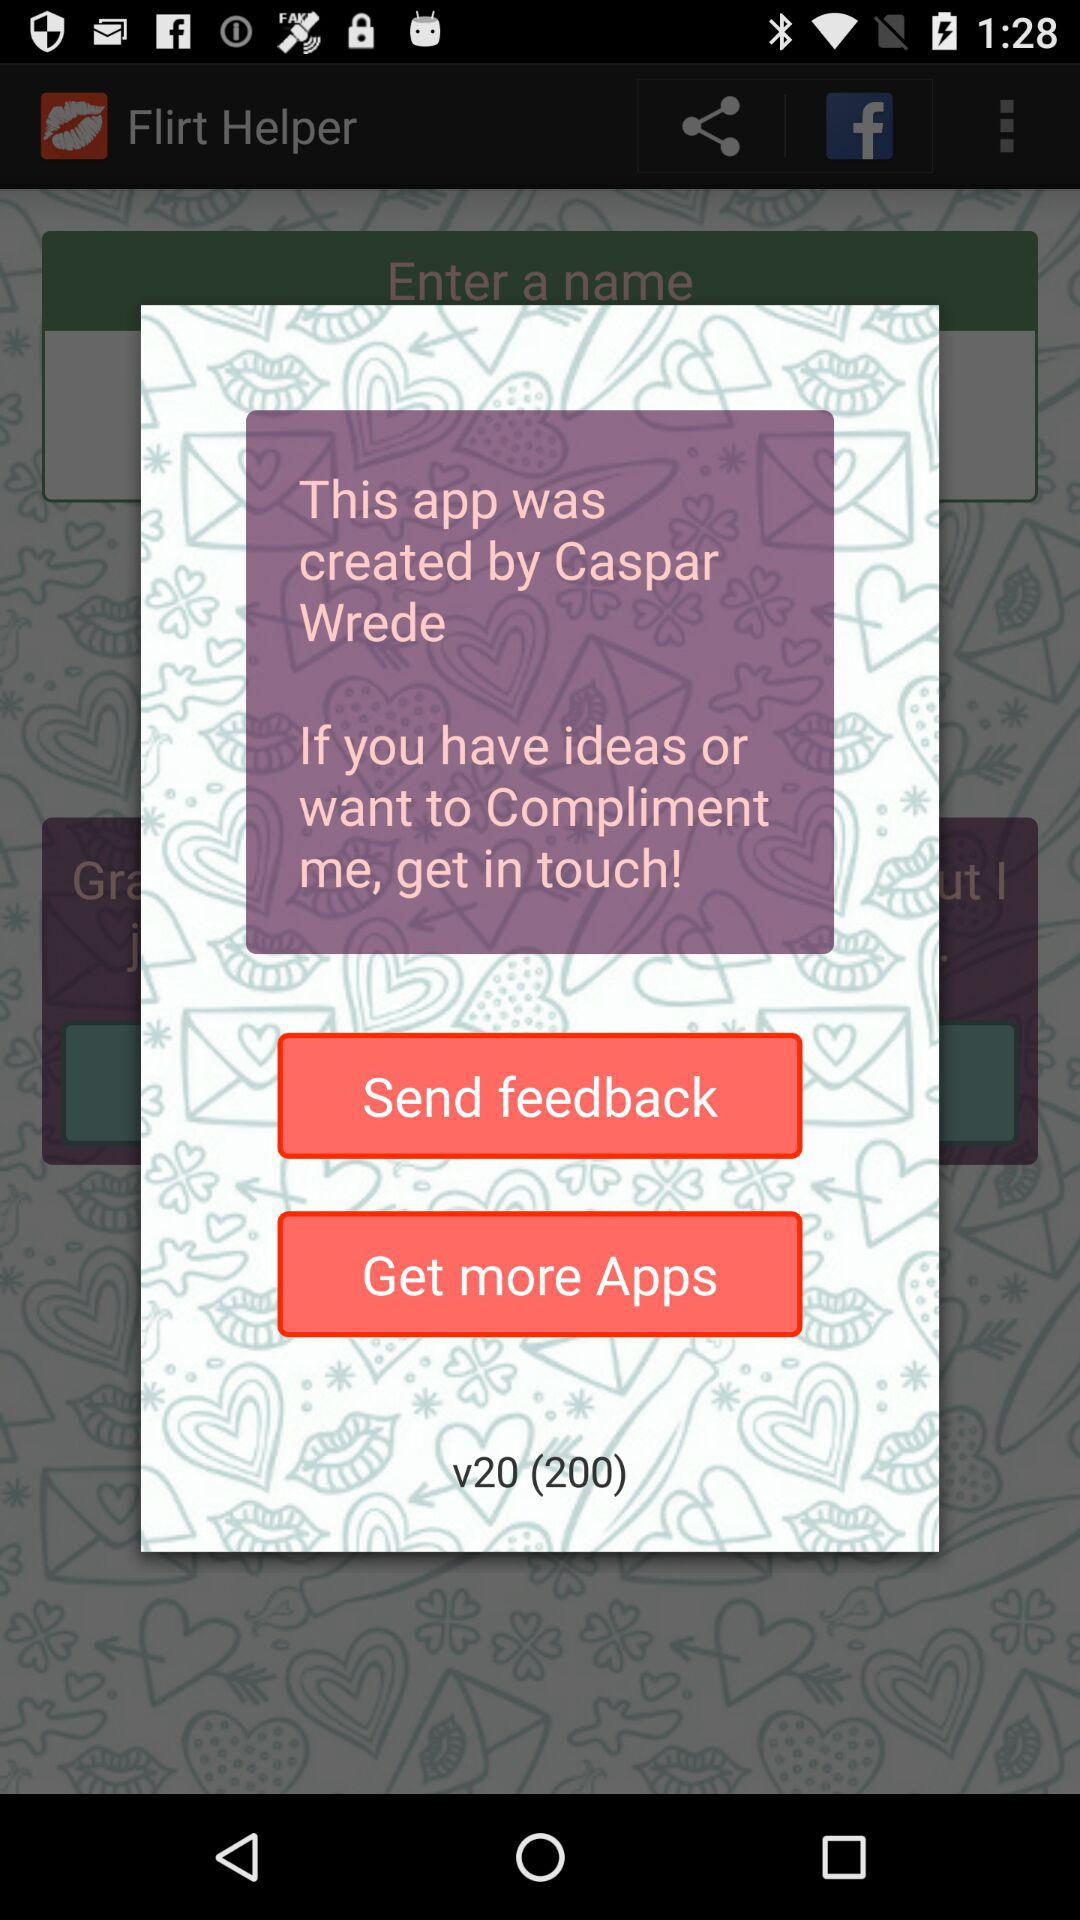By whom was the application created? The application was created by Caspar Wrede. 